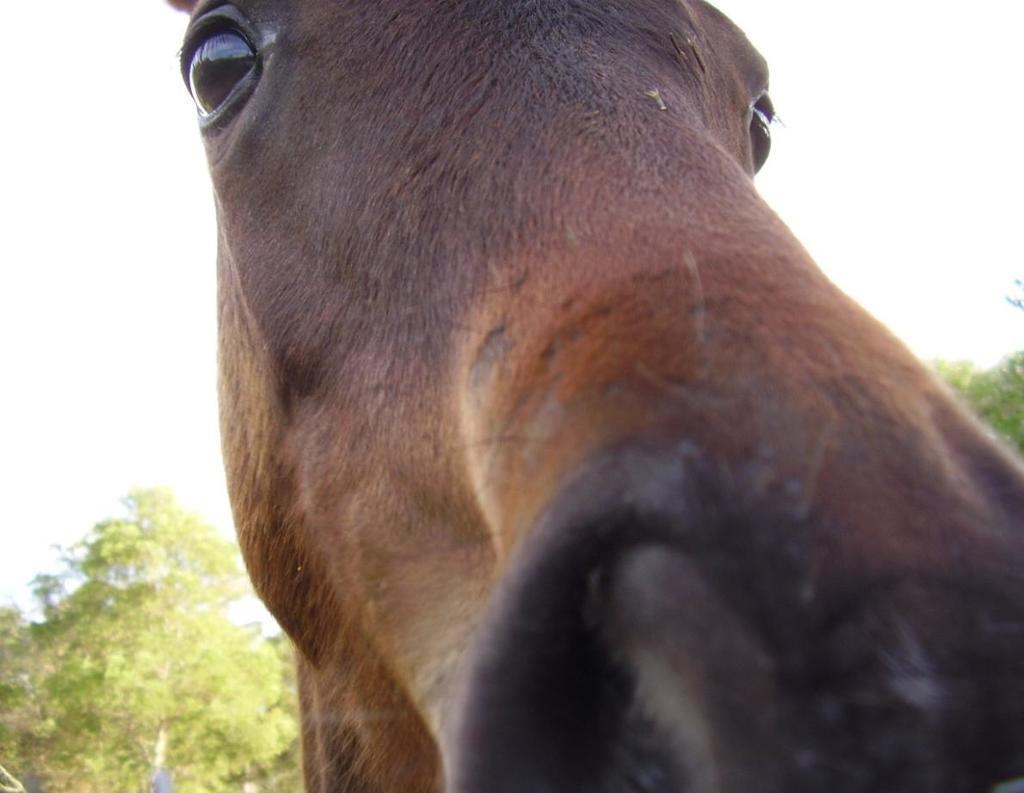In one or two sentences, can you explain what this image depicts? In the center of the image we can see an animal. At the bottom of the image we can see the trees. In the background of the image we can see the sky. 